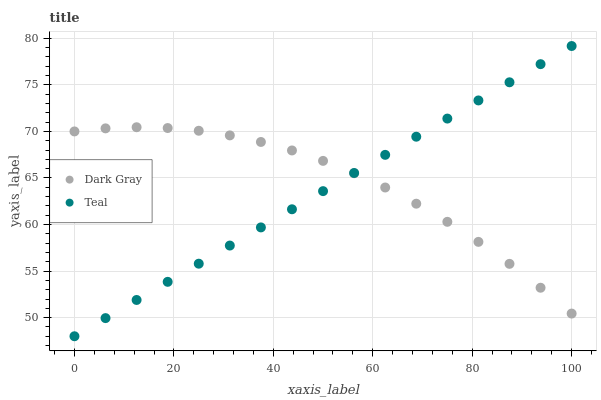Does Teal have the minimum area under the curve?
Answer yes or no. Yes. Does Dark Gray have the maximum area under the curve?
Answer yes or no. Yes. Does Teal have the maximum area under the curve?
Answer yes or no. No. Is Teal the smoothest?
Answer yes or no. Yes. Is Dark Gray the roughest?
Answer yes or no. Yes. Is Teal the roughest?
Answer yes or no. No. Does Teal have the lowest value?
Answer yes or no. Yes. Does Teal have the highest value?
Answer yes or no. Yes. Does Teal intersect Dark Gray?
Answer yes or no. Yes. Is Teal less than Dark Gray?
Answer yes or no. No. Is Teal greater than Dark Gray?
Answer yes or no. No. 